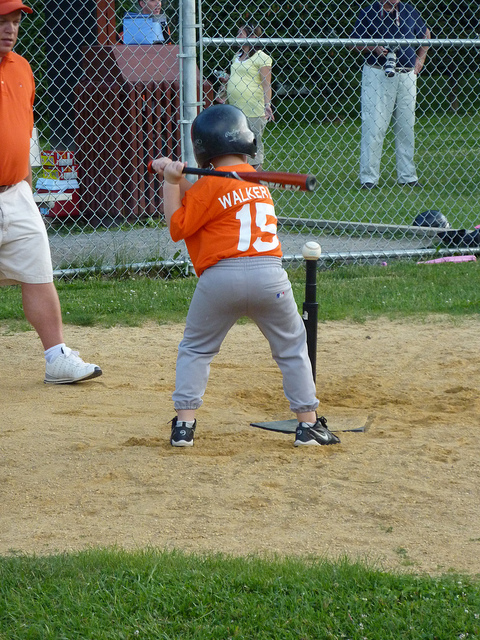<image>What color are the batter's socks? I am not sure about the color of batter's socks. It could be either white or gray. What brand of bat? I don't know the brand of the bat. It can be 'telex', 'beday', 'rawlings', 'oakley', 'reflex', 'easton' or 'wilson'. What color are the batter's socks? It can be seen that the batter's socks are white. What brand of bat? I don't know what brand of bat it is. It can be 'telex', 'beday', 'rawlings', 'oakley', 'reflex', 'easton', 'baseball', or 'wilson'. 